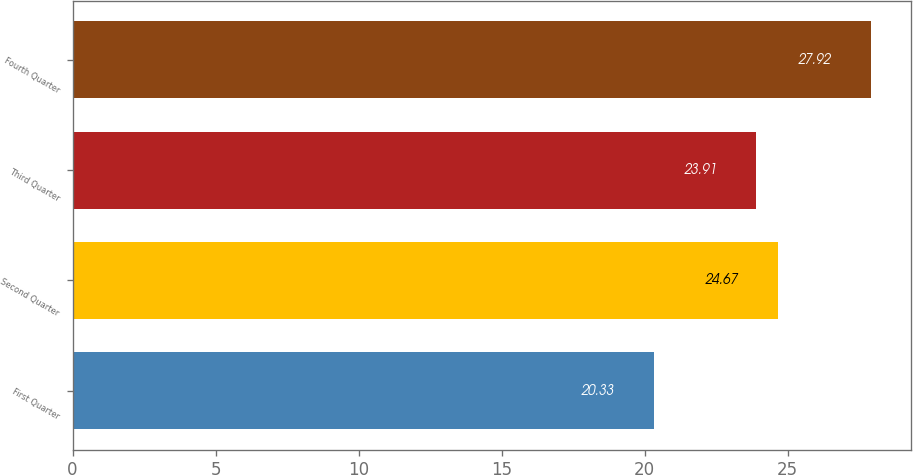<chart> <loc_0><loc_0><loc_500><loc_500><bar_chart><fcel>First Quarter<fcel>Second Quarter<fcel>Third Quarter<fcel>Fourth Quarter<nl><fcel>20.33<fcel>24.67<fcel>23.91<fcel>27.92<nl></chart> 